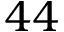Convert formula to latex. <formula><loc_0><loc_0><loc_500><loc_500>4 4</formula> 